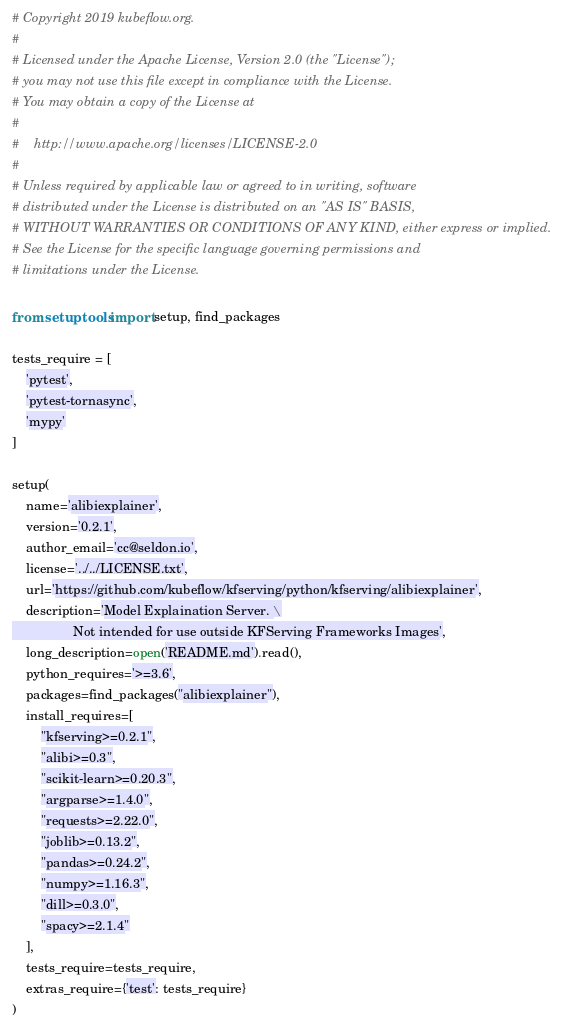<code> <loc_0><loc_0><loc_500><loc_500><_Python_># Copyright 2019 kubeflow.org.
#
# Licensed under the Apache License, Version 2.0 (the "License");
# you may not use this file except in compliance with the License.
# You may obtain a copy of the License at
#
#    http://www.apache.org/licenses/LICENSE-2.0
#
# Unless required by applicable law or agreed to in writing, software
# distributed under the License is distributed on an "AS IS" BASIS,
# WITHOUT WARRANTIES OR CONDITIONS OF ANY KIND, either express or implied.
# See the License for the specific language governing permissions and
# limitations under the License.

from setuptools import setup, find_packages

tests_require = [
    'pytest',
    'pytest-tornasync',
    'mypy'
]

setup(
    name='alibiexplainer',
    version='0.2.1',
    author_email='cc@seldon.io',
    license='../../LICENSE.txt',
    url='https://github.com/kubeflow/kfserving/python/kfserving/alibiexplainer',
    description='Model Explaination Server. \
                 Not intended for use outside KFServing Frameworks Images',
    long_description=open('README.md').read(),
    python_requires='>=3.6',
    packages=find_packages("alibiexplainer"),
    install_requires=[
        "kfserving>=0.2.1",
        "alibi>=0.3",
        "scikit-learn>=0.20.3",
        "argparse>=1.4.0",
        "requests>=2.22.0",
        "joblib>=0.13.2",
        "pandas>=0.24.2",
        "numpy>=1.16.3",
        "dill>=0.3.0",
        "spacy>=2.1.4"
    ],
    tests_require=tests_require,
    extras_require={'test': tests_require}
)
</code> 